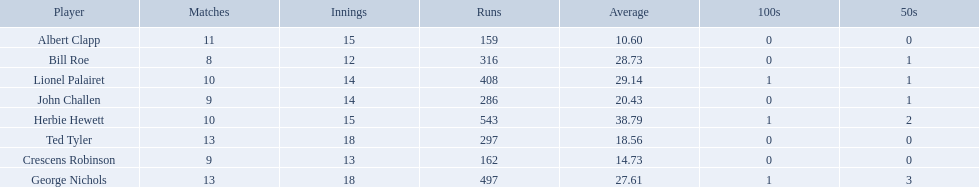Who are the players in somerset county cricket club in 1890? Herbie Hewett, Lionel Palairet, Bill Roe, George Nichols, John Challen, Ted Tyler, Crescens Robinson, Albert Clapp. Who is the only player to play less than 13 innings? Bill Roe. 